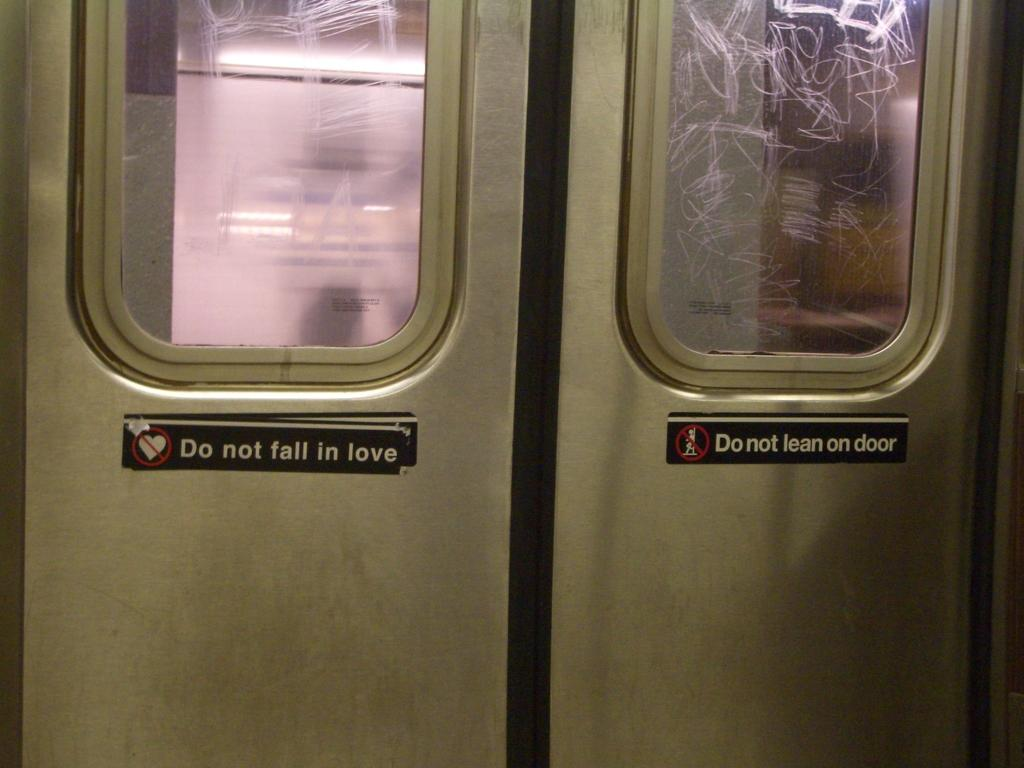What is the main feature of the image? The main feature of the image is a closed door. What can be seen on the door? The door has glass windows and text on it. What type of chain is hanging from the door in the image? There is no chain hanging from the door in the image. What picture is displayed on the door? There is no picture displayed on the door; it only has text and glass windows. 